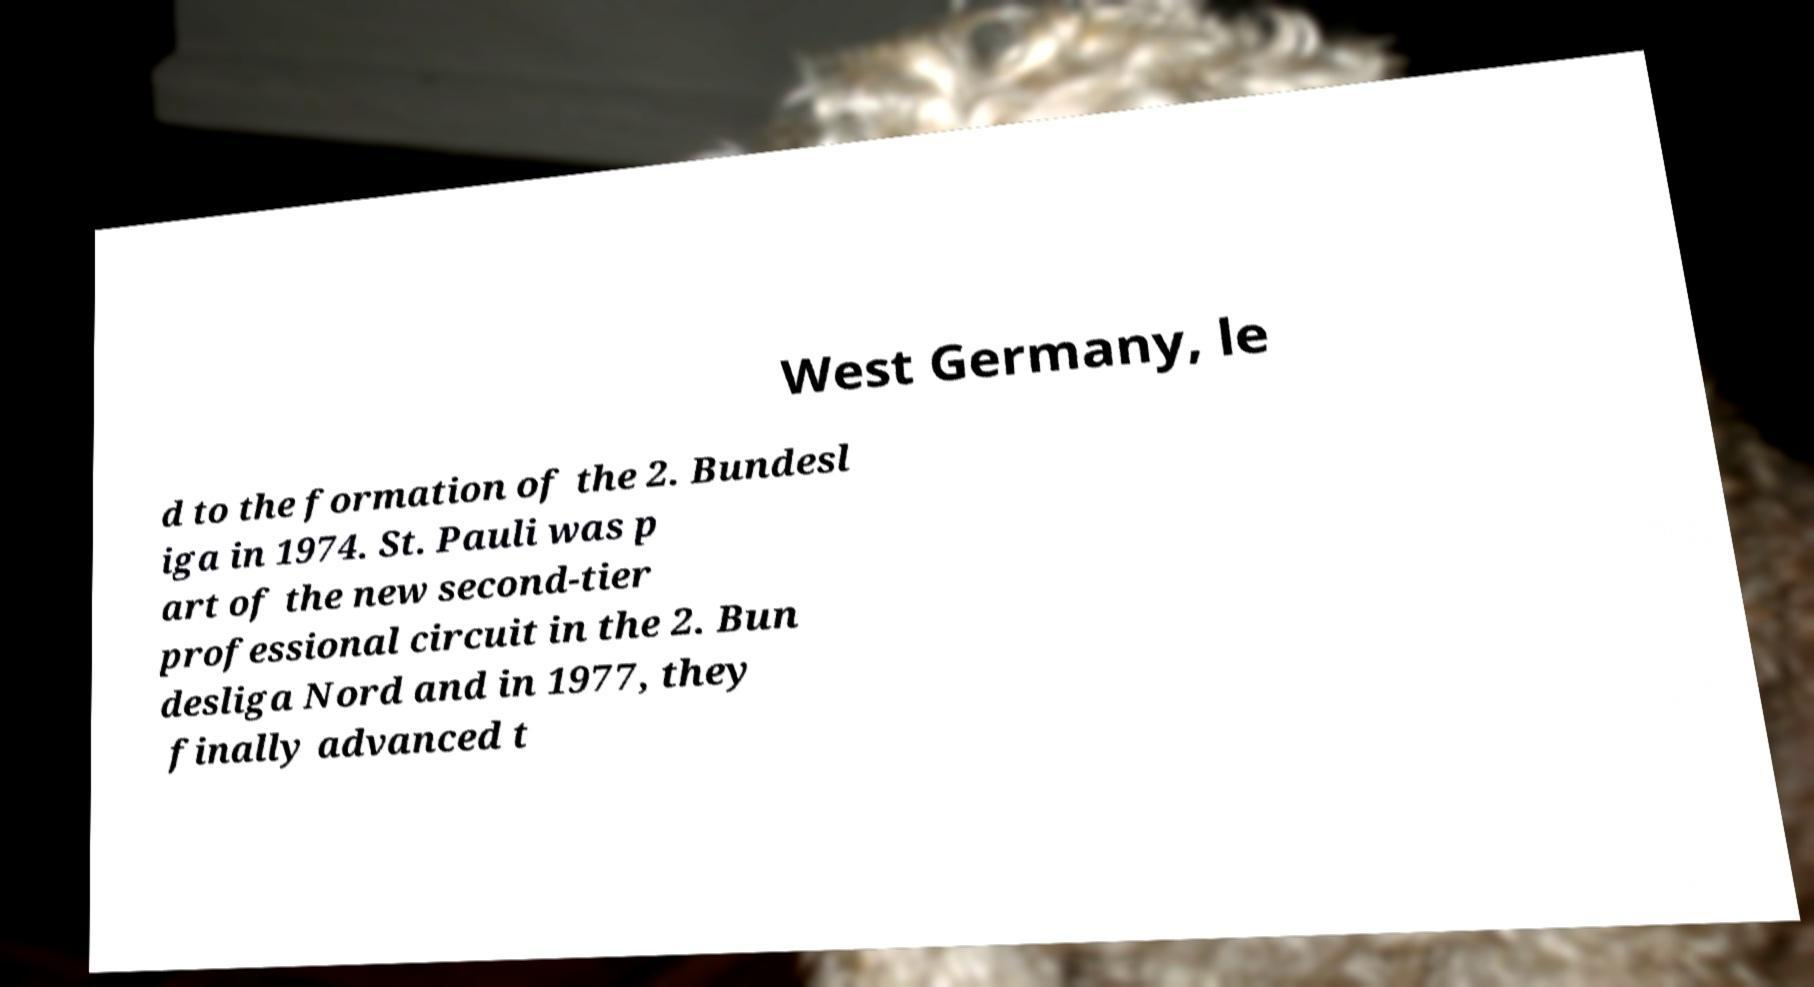For documentation purposes, I need the text within this image transcribed. Could you provide that? West Germany, le d to the formation of the 2. Bundesl iga in 1974. St. Pauli was p art of the new second-tier professional circuit in the 2. Bun desliga Nord and in 1977, they finally advanced t 